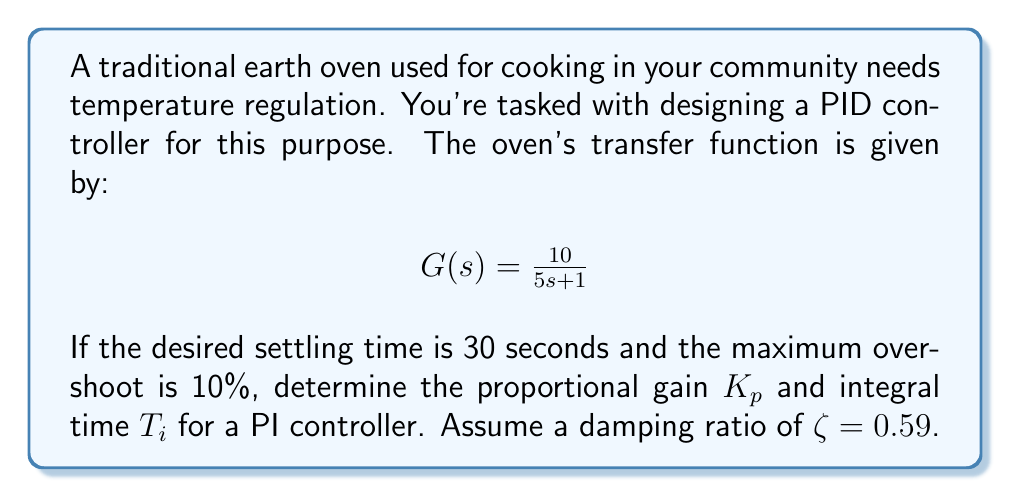Help me with this question. To design a PI controller for the given system, we'll follow these steps:

1) The closed-loop transfer function of a system with PI control is:

   $$T(s) = \frac{K_p(1 + \frac{1}{T_is})G(s)}{1 + K_p(1 + \frac{1}{T_is})G(s)}$$

2) For a second-order system, we can relate the damping ratio $\zeta$ and natural frequency $\omega_n$ to the settling time $t_s$ and maximum overshoot $M_p$:

   $$t_s \approx \frac{4}{\zeta\omega_n}$$
   $$M_p = e^{-\frac{\pi\zeta}{\sqrt{1-\zeta^2}}}$$

3) Given $t_s = 30s$ and $M_p = 10\% = 0.1$, we can confirm $\zeta = 0.59$ and calculate $\omega_n$:

   $$30 \approx \frac{4}{0.59\omega_n}$$
   $$\omega_n \approx 0.226$$

4) The characteristic equation of the closed-loop system should match the standard form:

   $$s^2 + 2\zeta\omega_n s + \omega_n^2$$

5) Expanding the denominator of $T(s)$ and equating coefficients:

   $$s^2 + (0.2 + 10K_p)s + \frac{10K_p}{T_i} = s^2 + 2(0.59)(0.226)s + 0.226^2$$

6) Equating coefficients:

   $$0.2 + 10K_p = 2(0.59)(0.226) = 0.267$$
   $$\frac{10K_p}{T_i} = 0.226^2 = 0.051$$

7) Solving these equations:

   $$K_p = 0.0067$$
   $$T_i = \frac{10K_p}{0.051} = 1.314$$
Answer: The proportional gain $K_p = 0.0067$ and the integral time $T_i = 1.314$ seconds. 